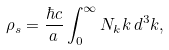<formula> <loc_0><loc_0><loc_500><loc_500>\rho _ { s } = \frac { \hbar { c } } { a } \int _ { 0 } ^ { \infty } N _ { k } k \, d ^ { 3 } k ,</formula> 